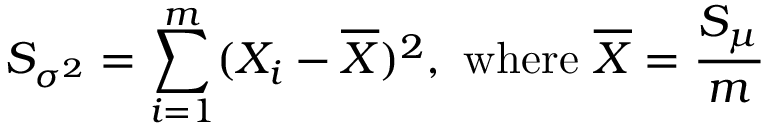<formula> <loc_0><loc_0><loc_500><loc_500>S _ { \sigma ^ { 2 } } = \sum _ { i = 1 } ^ { m } ( X _ { i } - { \overline { X } } ) ^ { 2 } , { w h e r e } { \overline { X } } = { \frac { S _ { \mu } } { m } }</formula> 